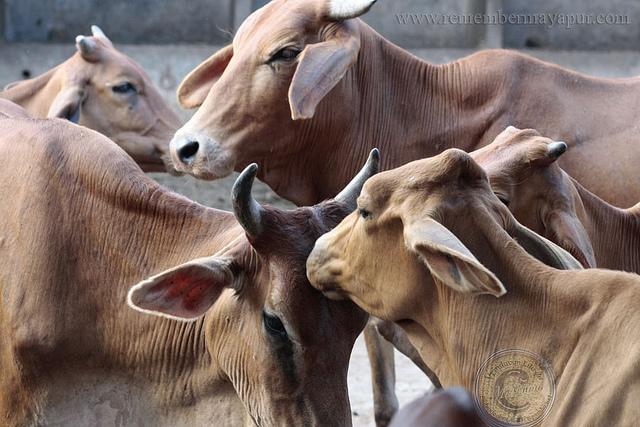How many animals are there?
Concise answer only. 5. Do all the animal have visible horns?
Keep it brief. No. What color are the animals?
Concise answer only. Brown. 